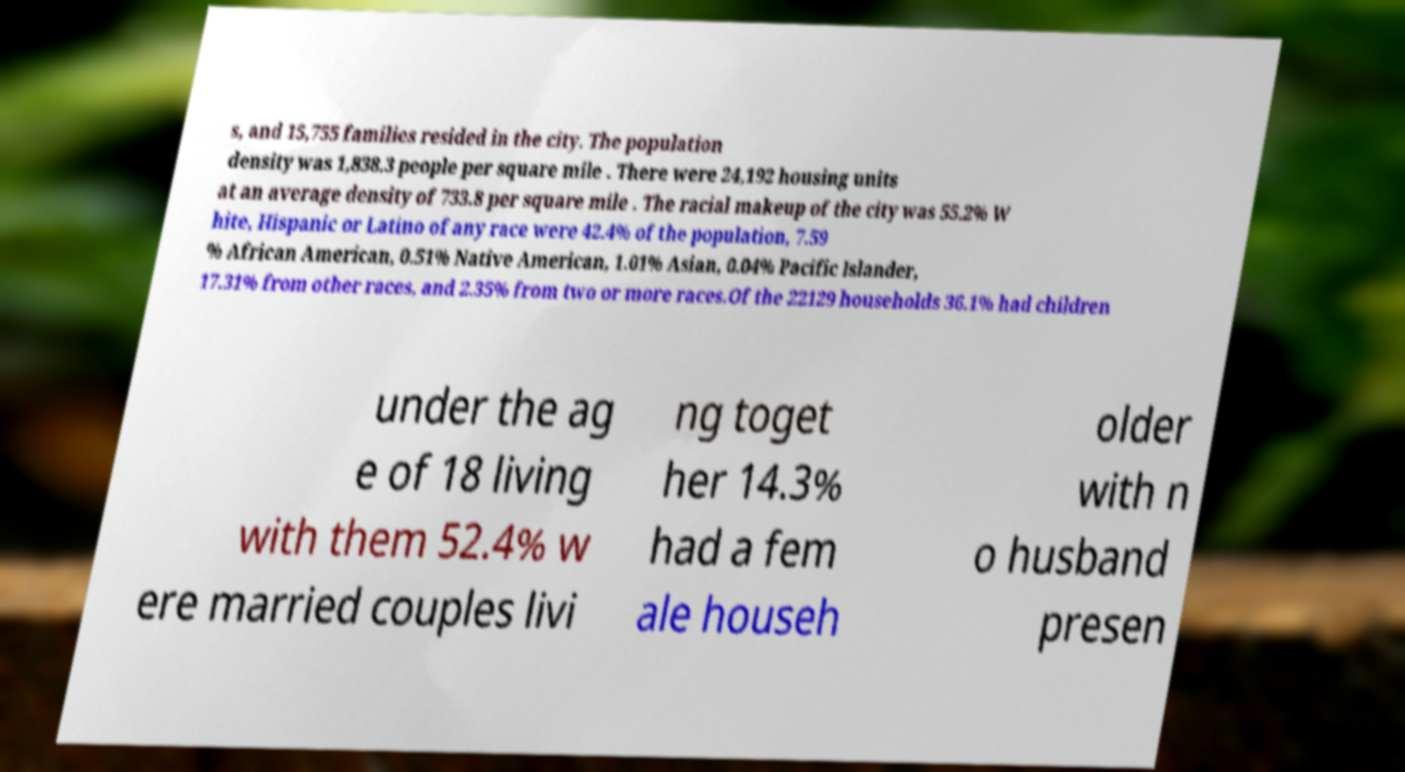Could you assist in decoding the text presented in this image and type it out clearly? s, and 15,755 families resided in the city. The population density was 1,838.3 people per square mile . There were 24,192 housing units at an average density of 733.8 per square mile . The racial makeup of the city was 55.2% W hite, Hispanic or Latino of any race were 42.4% of the population, 7.59 % African American, 0.51% Native American, 1.01% Asian, 0.04% Pacific Islander, 17.31% from other races, and 2.35% from two or more races.Of the 22129 households 36.1% had children under the ag e of 18 living with them 52.4% w ere married couples livi ng toget her 14.3% had a fem ale househ older with n o husband presen 